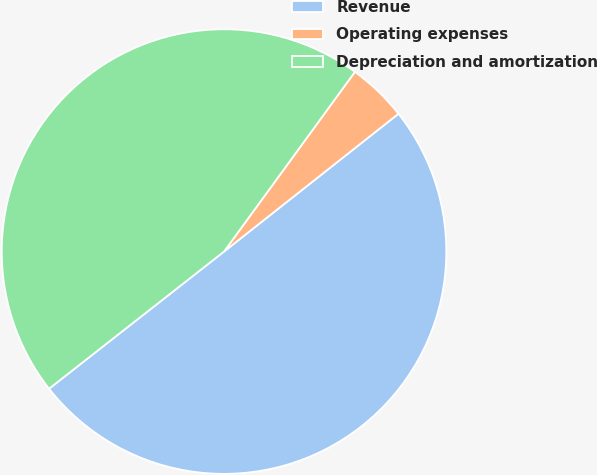Convert chart to OTSL. <chart><loc_0><loc_0><loc_500><loc_500><pie_chart><fcel>Revenue<fcel>Operating expenses<fcel>Depreciation and amortization<nl><fcel>50.06%<fcel>4.34%<fcel>45.6%<nl></chart> 